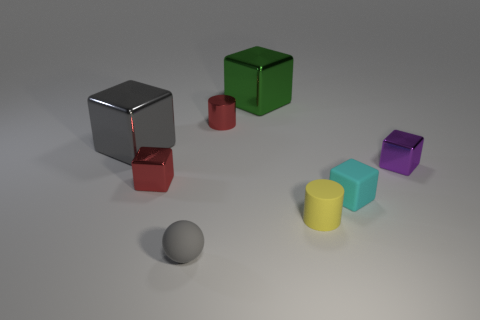What size is the red object that is made of the same material as the red block?
Provide a short and direct response. Small. Are there fewer red metal cubes than tiny cylinders?
Ensure brevity in your answer.  Yes. What material is the cylinder in front of the small shiny object right of the tiny matte object that is behind the yellow rubber cylinder made of?
Provide a short and direct response. Rubber. Is the material of the cylinder that is to the right of the green thing the same as the small block left of the tiny cyan thing?
Keep it short and to the point. No. What is the size of the metal object that is right of the red cylinder and left of the matte cylinder?
Offer a very short reply. Large. What material is the green thing that is the same size as the gray metal thing?
Offer a terse response. Metal. What number of matte things are to the left of the cylinder that is in front of the small thing on the right side of the cyan block?
Offer a very short reply. 1. There is a cylinder that is behind the cyan block; does it have the same color as the small thing that is to the left of the matte sphere?
Your response must be concise. Yes. There is a tiny block that is both on the right side of the tiny yellow matte thing and on the left side of the small purple metal cube; what is its color?
Offer a terse response. Cyan. How many yellow rubber cylinders have the same size as the purple shiny cube?
Give a very brief answer. 1. 